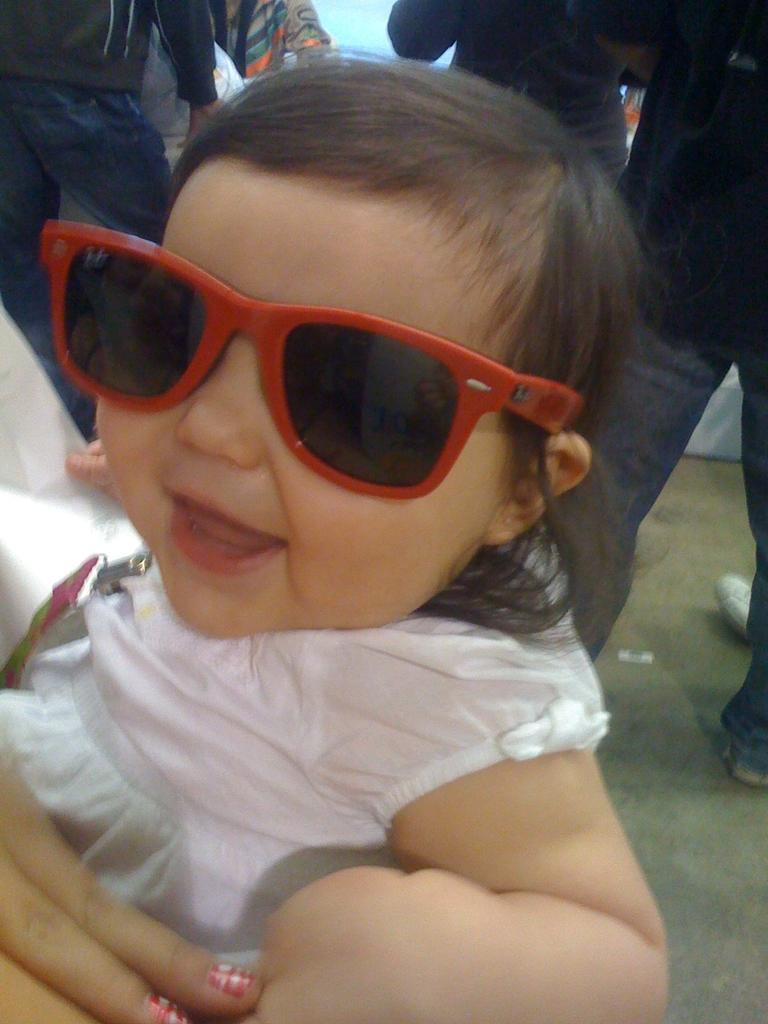What is the main subject of the picture? The main subject of the picture is a kid. What is the kid doing in the picture? The kid is smiling in the picture. What is the kid wearing in the picture? The kid is wearing a pink dress and spectacles in the picture. Can you describe the people in the background of the picture? There are persons standing in the background of the picture. What type of cough medicine is the kid taking in the picture? There is no indication in the image that the kid is taking any cough medicine, as the focus is on the kid's smile and clothing. 